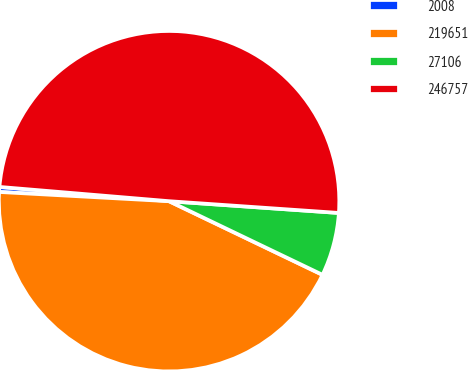Convert chart. <chart><loc_0><loc_0><loc_500><loc_500><pie_chart><fcel>2008<fcel>219651<fcel>27106<fcel>246757<nl><fcel>0.47%<fcel>43.74%<fcel>6.02%<fcel>49.76%<nl></chart> 